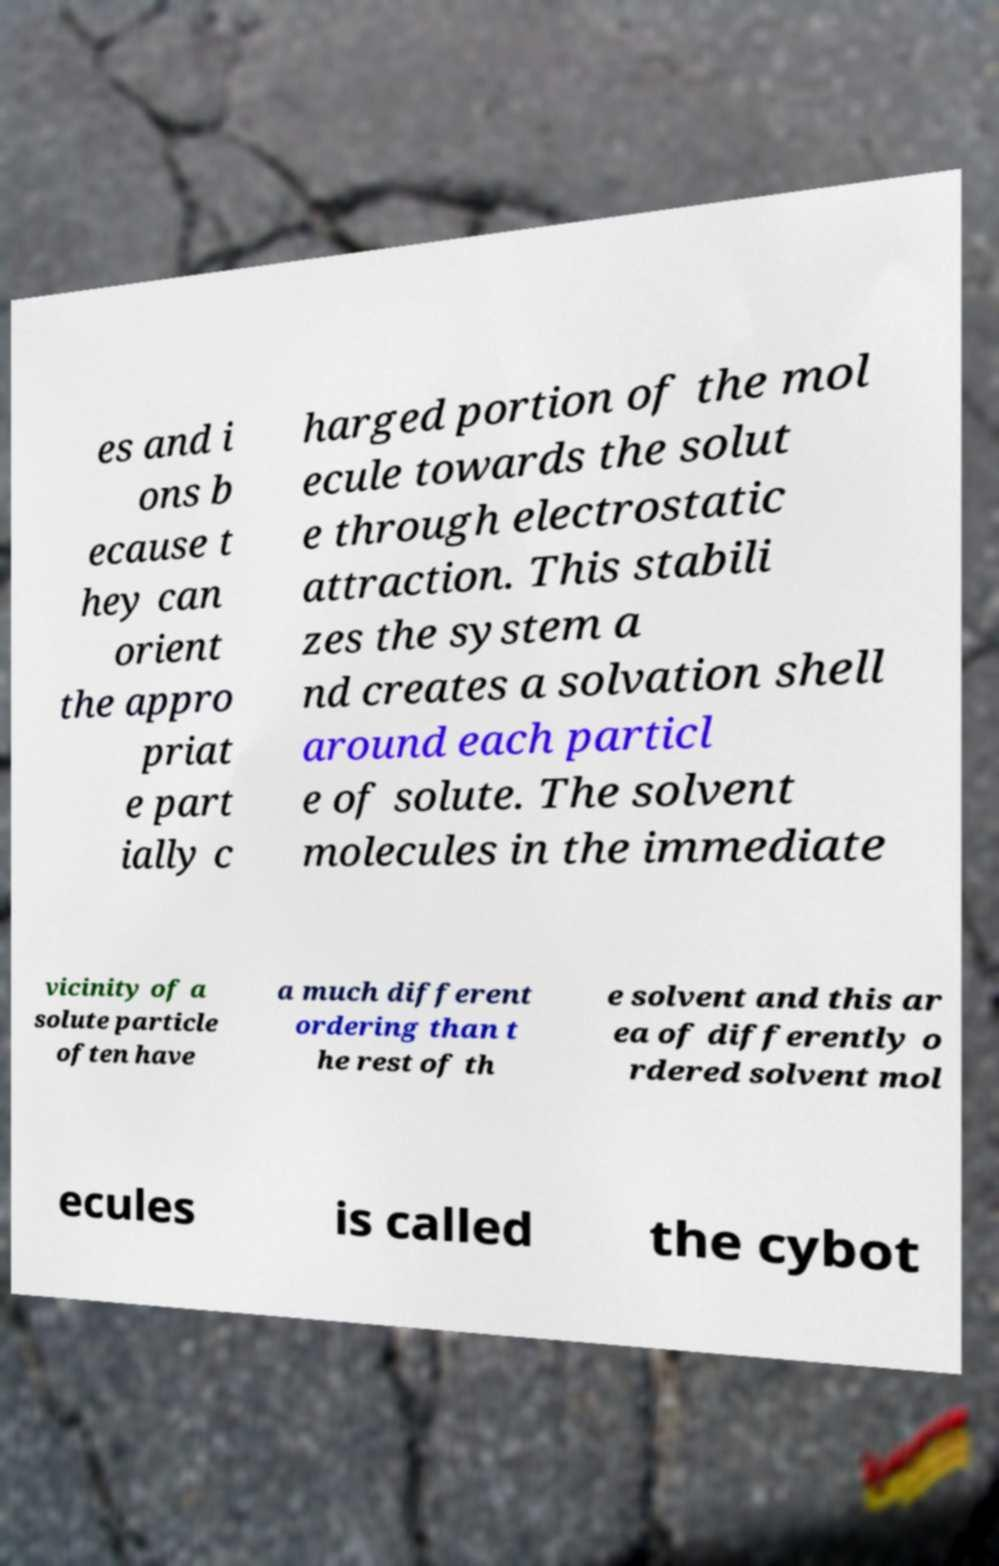Could you extract and type out the text from this image? es and i ons b ecause t hey can orient the appro priat e part ially c harged portion of the mol ecule towards the solut e through electrostatic attraction. This stabili zes the system a nd creates a solvation shell around each particl e of solute. The solvent molecules in the immediate vicinity of a solute particle often have a much different ordering than t he rest of th e solvent and this ar ea of differently o rdered solvent mol ecules is called the cybot 